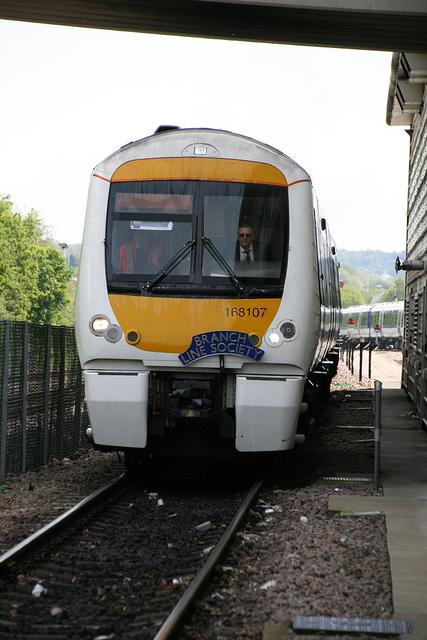What color is the train?
Concise answer only. Yellow and white. What two colors is the train?
Answer briefly. White and yellow. Where are the last three numbers 107?
Give a very brief answer. Front of train. 